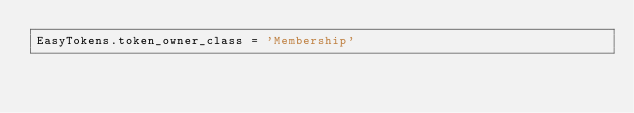Convert code to text. <code><loc_0><loc_0><loc_500><loc_500><_Ruby_>EasyTokens.token_owner_class = 'Membership'
</code> 